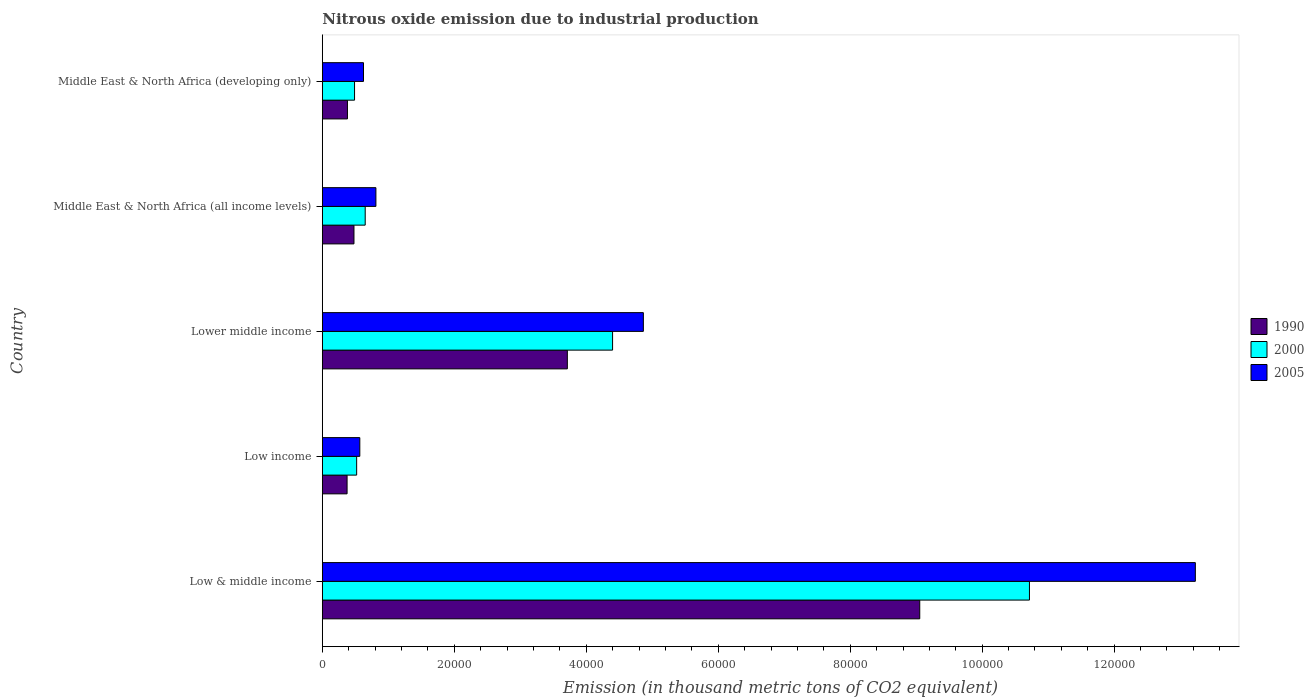How many different coloured bars are there?
Your response must be concise. 3. How many groups of bars are there?
Provide a short and direct response. 5. Are the number of bars per tick equal to the number of legend labels?
Offer a terse response. Yes. How many bars are there on the 5th tick from the top?
Offer a terse response. 3. What is the label of the 1st group of bars from the top?
Your answer should be compact. Middle East & North Africa (developing only). What is the amount of nitrous oxide emitted in 2000 in Low & middle income?
Provide a short and direct response. 1.07e+05. Across all countries, what is the maximum amount of nitrous oxide emitted in 2000?
Your response must be concise. 1.07e+05. Across all countries, what is the minimum amount of nitrous oxide emitted in 2005?
Your response must be concise. 5680.8. In which country was the amount of nitrous oxide emitted in 2005 minimum?
Your answer should be very brief. Low income. What is the total amount of nitrous oxide emitted in 2000 in the graph?
Provide a short and direct response. 1.68e+05. What is the difference between the amount of nitrous oxide emitted in 2005 in Low & middle income and that in Middle East & North Africa (developing only)?
Provide a succinct answer. 1.26e+05. What is the difference between the amount of nitrous oxide emitted in 2000 in Lower middle income and the amount of nitrous oxide emitted in 1990 in Low income?
Keep it short and to the point. 4.02e+04. What is the average amount of nitrous oxide emitted in 2000 per country?
Your answer should be very brief. 3.35e+04. What is the difference between the amount of nitrous oxide emitted in 2005 and amount of nitrous oxide emitted in 2000 in Low income?
Offer a very short reply. 479.3. What is the ratio of the amount of nitrous oxide emitted in 2000 in Low & middle income to that in Middle East & North Africa (developing only)?
Your answer should be compact. 21.95. Is the difference between the amount of nitrous oxide emitted in 2005 in Low income and Middle East & North Africa (developing only) greater than the difference between the amount of nitrous oxide emitted in 2000 in Low income and Middle East & North Africa (developing only)?
Offer a terse response. No. What is the difference between the highest and the second highest amount of nitrous oxide emitted in 2005?
Your response must be concise. 8.37e+04. What is the difference between the highest and the lowest amount of nitrous oxide emitted in 2005?
Give a very brief answer. 1.27e+05. In how many countries, is the amount of nitrous oxide emitted in 1990 greater than the average amount of nitrous oxide emitted in 1990 taken over all countries?
Offer a terse response. 2. Is the sum of the amount of nitrous oxide emitted in 1990 in Low & middle income and Low income greater than the maximum amount of nitrous oxide emitted in 2000 across all countries?
Offer a terse response. No. How many bars are there?
Give a very brief answer. 15. What is the difference between two consecutive major ticks on the X-axis?
Provide a succinct answer. 2.00e+04. Does the graph contain grids?
Provide a short and direct response. No. Where does the legend appear in the graph?
Offer a very short reply. Center right. How many legend labels are there?
Make the answer very short. 3. What is the title of the graph?
Ensure brevity in your answer.  Nitrous oxide emission due to industrial production. Does "2001" appear as one of the legend labels in the graph?
Your answer should be compact. No. What is the label or title of the X-axis?
Provide a short and direct response. Emission (in thousand metric tons of CO2 equivalent). What is the Emission (in thousand metric tons of CO2 equivalent) in 1990 in Low & middle income?
Keep it short and to the point. 9.05e+04. What is the Emission (in thousand metric tons of CO2 equivalent) of 2000 in Low & middle income?
Ensure brevity in your answer.  1.07e+05. What is the Emission (in thousand metric tons of CO2 equivalent) in 2005 in Low & middle income?
Give a very brief answer. 1.32e+05. What is the Emission (in thousand metric tons of CO2 equivalent) in 1990 in Low income?
Give a very brief answer. 3751.3. What is the Emission (in thousand metric tons of CO2 equivalent) in 2000 in Low income?
Provide a succinct answer. 5201.5. What is the Emission (in thousand metric tons of CO2 equivalent) of 2005 in Low income?
Keep it short and to the point. 5680.8. What is the Emission (in thousand metric tons of CO2 equivalent) of 1990 in Lower middle income?
Your response must be concise. 3.71e+04. What is the Emission (in thousand metric tons of CO2 equivalent) in 2000 in Lower middle income?
Provide a succinct answer. 4.40e+04. What is the Emission (in thousand metric tons of CO2 equivalent) in 2005 in Lower middle income?
Provide a short and direct response. 4.87e+04. What is the Emission (in thousand metric tons of CO2 equivalent) in 1990 in Middle East & North Africa (all income levels)?
Your answer should be very brief. 4795.2. What is the Emission (in thousand metric tons of CO2 equivalent) of 2000 in Middle East & North Africa (all income levels)?
Provide a succinct answer. 6497. What is the Emission (in thousand metric tons of CO2 equivalent) in 2005 in Middle East & North Africa (all income levels)?
Provide a short and direct response. 8118.6. What is the Emission (in thousand metric tons of CO2 equivalent) of 1990 in Middle East & North Africa (developing only)?
Your answer should be very brief. 3806.6. What is the Emission (in thousand metric tons of CO2 equivalent) in 2000 in Middle East & North Africa (developing only)?
Your response must be concise. 4882.9. What is the Emission (in thousand metric tons of CO2 equivalent) of 2005 in Middle East & North Africa (developing only)?
Offer a very short reply. 6239.6. Across all countries, what is the maximum Emission (in thousand metric tons of CO2 equivalent) in 1990?
Your answer should be very brief. 9.05e+04. Across all countries, what is the maximum Emission (in thousand metric tons of CO2 equivalent) of 2000?
Your answer should be compact. 1.07e+05. Across all countries, what is the maximum Emission (in thousand metric tons of CO2 equivalent) of 2005?
Provide a short and direct response. 1.32e+05. Across all countries, what is the minimum Emission (in thousand metric tons of CO2 equivalent) in 1990?
Provide a short and direct response. 3751.3. Across all countries, what is the minimum Emission (in thousand metric tons of CO2 equivalent) in 2000?
Your response must be concise. 4882.9. Across all countries, what is the minimum Emission (in thousand metric tons of CO2 equivalent) in 2005?
Provide a short and direct response. 5680.8. What is the total Emission (in thousand metric tons of CO2 equivalent) of 1990 in the graph?
Offer a very short reply. 1.40e+05. What is the total Emission (in thousand metric tons of CO2 equivalent) of 2000 in the graph?
Provide a short and direct response. 1.68e+05. What is the total Emission (in thousand metric tons of CO2 equivalent) in 2005 in the graph?
Offer a very short reply. 2.01e+05. What is the difference between the Emission (in thousand metric tons of CO2 equivalent) of 1990 in Low & middle income and that in Low income?
Provide a short and direct response. 8.68e+04. What is the difference between the Emission (in thousand metric tons of CO2 equivalent) in 2000 in Low & middle income and that in Low income?
Your answer should be compact. 1.02e+05. What is the difference between the Emission (in thousand metric tons of CO2 equivalent) of 2005 in Low & middle income and that in Low income?
Keep it short and to the point. 1.27e+05. What is the difference between the Emission (in thousand metric tons of CO2 equivalent) in 1990 in Low & middle income and that in Lower middle income?
Your answer should be compact. 5.34e+04. What is the difference between the Emission (in thousand metric tons of CO2 equivalent) in 2000 in Low & middle income and that in Lower middle income?
Your answer should be very brief. 6.32e+04. What is the difference between the Emission (in thousand metric tons of CO2 equivalent) in 2005 in Low & middle income and that in Lower middle income?
Offer a terse response. 8.37e+04. What is the difference between the Emission (in thousand metric tons of CO2 equivalent) in 1990 in Low & middle income and that in Middle East & North Africa (all income levels)?
Your answer should be very brief. 8.57e+04. What is the difference between the Emission (in thousand metric tons of CO2 equivalent) of 2000 in Low & middle income and that in Middle East & North Africa (all income levels)?
Ensure brevity in your answer.  1.01e+05. What is the difference between the Emission (in thousand metric tons of CO2 equivalent) in 2005 in Low & middle income and that in Middle East & North Africa (all income levels)?
Make the answer very short. 1.24e+05. What is the difference between the Emission (in thousand metric tons of CO2 equivalent) in 1990 in Low & middle income and that in Middle East & North Africa (developing only)?
Ensure brevity in your answer.  8.67e+04. What is the difference between the Emission (in thousand metric tons of CO2 equivalent) in 2000 in Low & middle income and that in Middle East & North Africa (developing only)?
Provide a succinct answer. 1.02e+05. What is the difference between the Emission (in thousand metric tons of CO2 equivalent) in 2005 in Low & middle income and that in Middle East & North Africa (developing only)?
Ensure brevity in your answer.  1.26e+05. What is the difference between the Emission (in thousand metric tons of CO2 equivalent) in 1990 in Low income and that in Lower middle income?
Your response must be concise. -3.34e+04. What is the difference between the Emission (in thousand metric tons of CO2 equivalent) of 2000 in Low income and that in Lower middle income?
Provide a short and direct response. -3.88e+04. What is the difference between the Emission (in thousand metric tons of CO2 equivalent) of 2005 in Low income and that in Lower middle income?
Ensure brevity in your answer.  -4.30e+04. What is the difference between the Emission (in thousand metric tons of CO2 equivalent) of 1990 in Low income and that in Middle East & North Africa (all income levels)?
Keep it short and to the point. -1043.9. What is the difference between the Emission (in thousand metric tons of CO2 equivalent) of 2000 in Low income and that in Middle East & North Africa (all income levels)?
Give a very brief answer. -1295.5. What is the difference between the Emission (in thousand metric tons of CO2 equivalent) of 2005 in Low income and that in Middle East & North Africa (all income levels)?
Keep it short and to the point. -2437.8. What is the difference between the Emission (in thousand metric tons of CO2 equivalent) of 1990 in Low income and that in Middle East & North Africa (developing only)?
Your answer should be compact. -55.3. What is the difference between the Emission (in thousand metric tons of CO2 equivalent) in 2000 in Low income and that in Middle East & North Africa (developing only)?
Offer a very short reply. 318.6. What is the difference between the Emission (in thousand metric tons of CO2 equivalent) of 2005 in Low income and that in Middle East & North Africa (developing only)?
Offer a terse response. -558.8. What is the difference between the Emission (in thousand metric tons of CO2 equivalent) of 1990 in Lower middle income and that in Middle East & North Africa (all income levels)?
Your answer should be very brief. 3.23e+04. What is the difference between the Emission (in thousand metric tons of CO2 equivalent) in 2000 in Lower middle income and that in Middle East & North Africa (all income levels)?
Ensure brevity in your answer.  3.75e+04. What is the difference between the Emission (in thousand metric tons of CO2 equivalent) in 2005 in Lower middle income and that in Middle East & North Africa (all income levels)?
Your answer should be very brief. 4.05e+04. What is the difference between the Emission (in thousand metric tons of CO2 equivalent) in 1990 in Lower middle income and that in Middle East & North Africa (developing only)?
Offer a very short reply. 3.33e+04. What is the difference between the Emission (in thousand metric tons of CO2 equivalent) in 2000 in Lower middle income and that in Middle East & North Africa (developing only)?
Offer a very short reply. 3.91e+04. What is the difference between the Emission (in thousand metric tons of CO2 equivalent) in 2005 in Lower middle income and that in Middle East & North Africa (developing only)?
Make the answer very short. 4.24e+04. What is the difference between the Emission (in thousand metric tons of CO2 equivalent) in 1990 in Middle East & North Africa (all income levels) and that in Middle East & North Africa (developing only)?
Your answer should be very brief. 988.6. What is the difference between the Emission (in thousand metric tons of CO2 equivalent) in 2000 in Middle East & North Africa (all income levels) and that in Middle East & North Africa (developing only)?
Ensure brevity in your answer.  1614.1. What is the difference between the Emission (in thousand metric tons of CO2 equivalent) of 2005 in Middle East & North Africa (all income levels) and that in Middle East & North Africa (developing only)?
Ensure brevity in your answer.  1879. What is the difference between the Emission (in thousand metric tons of CO2 equivalent) in 1990 in Low & middle income and the Emission (in thousand metric tons of CO2 equivalent) in 2000 in Low income?
Provide a succinct answer. 8.53e+04. What is the difference between the Emission (in thousand metric tons of CO2 equivalent) of 1990 in Low & middle income and the Emission (in thousand metric tons of CO2 equivalent) of 2005 in Low income?
Make the answer very short. 8.49e+04. What is the difference between the Emission (in thousand metric tons of CO2 equivalent) of 2000 in Low & middle income and the Emission (in thousand metric tons of CO2 equivalent) of 2005 in Low income?
Your response must be concise. 1.01e+05. What is the difference between the Emission (in thousand metric tons of CO2 equivalent) of 1990 in Low & middle income and the Emission (in thousand metric tons of CO2 equivalent) of 2000 in Lower middle income?
Your answer should be compact. 4.66e+04. What is the difference between the Emission (in thousand metric tons of CO2 equivalent) of 1990 in Low & middle income and the Emission (in thousand metric tons of CO2 equivalent) of 2005 in Lower middle income?
Offer a terse response. 4.19e+04. What is the difference between the Emission (in thousand metric tons of CO2 equivalent) of 2000 in Low & middle income and the Emission (in thousand metric tons of CO2 equivalent) of 2005 in Lower middle income?
Offer a terse response. 5.85e+04. What is the difference between the Emission (in thousand metric tons of CO2 equivalent) in 1990 in Low & middle income and the Emission (in thousand metric tons of CO2 equivalent) in 2000 in Middle East & North Africa (all income levels)?
Offer a terse response. 8.40e+04. What is the difference between the Emission (in thousand metric tons of CO2 equivalent) in 1990 in Low & middle income and the Emission (in thousand metric tons of CO2 equivalent) in 2005 in Middle East & North Africa (all income levels)?
Your answer should be very brief. 8.24e+04. What is the difference between the Emission (in thousand metric tons of CO2 equivalent) in 2000 in Low & middle income and the Emission (in thousand metric tons of CO2 equivalent) in 2005 in Middle East & North Africa (all income levels)?
Your answer should be very brief. 9.90e+04. What is the difference between the Emission (in thousand metric tons of CO2 equivalent) of 1990 in Low & middle income and the Emission (in thousand metric tons of CO2 equivalent) of 2000 in Middle East & North Africa (developing only)?
Make the answer very short. 8.57e+04. What is the difference between the Emission (in thousand metric tons of CO2 equivalent) in 1990 in Low & middle income and the Emission (in thousand metric tons of CO2 equivalent) in 2005 in Middle East & North Africa (developing only)?
Provide a succinct answer. 8.43e+04. What is the difference between the Emission (in thousand metric tons of CO2 equivalent) in 2000 in Low & middle income and the Emission (in thousand metric tons of CO2 equivalent) in 2005 in Middle East & North Africa (developing only)?
Provide a succinct answer. 1.01e+05. What is the difference between the Emission (in thousand metric tons of CO2 equivalent) of 1990 in Low income and the Emission (in thousand metric tons of CO2 equivalent) of 2000 in Lower middle income?
Your answer should be very brief. -4.02e+04. What is the difference between the Emission (in thousand metric tons of CO2 equivalent) of 1990 in Low income and the Emission (in thousand metric tons of CO2 equivalent) of 2005 in Lower middle income?
Ensure brevity in your answer.  -4.49e+04. What is the difference between the Emission (in thousand metric tons of CO2 equivalent) in 2000 in Low income and the Emission (in thousand metric tons of CO2 equivalent) in 2005 in Lower middle income?
Your answer should be very brief. -4.35e+04. What is the difference between the Emission (in thousand metric tons of CO2 equivalent) of 1990 in Low income and the Emission (in thousand metric tons of CO2 equivalent) of 2000 in Middle East & North Africa (all income levels)?
Give a very brief answer. -2745.7. What is the difference between the Emission (in thousand metric tons of CO2 equivalent) in 1990 in Low income and the Emission (in thousand metric tons of CO2 equivalent) in 2005 in Middle East & North Africa (all income levels)?
Provide a short and direct response. -4367.3. What is the difference between the Emission (in thousand metric tons of CO2 equivalent) in 2000 in Low income and the Emission (in thousand metric tons of CO2 equivalent) in 2005 in Middle East & North Africa (all income levels)?
Offer a very short reply. -2917.1. What is the difference between the Emission (in thousand metric tons of CO2 equivalent) of 1990 in Low income and the Emission (in thousand metric tons of CO2 equivalent) of 2000 in Middle East & North Africa (developing only)?
Keep it short and to the point. -1131.6. What is the difference between the Emission (in thousand metric tons of CO2 equivalent) of 1990 in Low income and the Emission (in thousand metric tons of CO2 equivalent) of 2005 in Middle East & North Africa (developing only)?
Offer a very short reply. -2488.3. What is the difference between the Emission (in thousand metric tons of CO2 equivalent) in 2000 in Low income and the Emission (in thousand metric tons of CO2 equivalent) in 2005 in Middle East & North Africa (developing only)?
Offer a very short reply. -1038.1. What is the difference between the Emission (in thousand metric tons of CO2 equivalent) of 1990 in Lower middle income and the Emission (in thousand metric tons of CO2 equivalent) of 2000 in Middle East & North Africa (all income levels)?
Your response must be concise. 3.06e+04. What is the difference between the Emission (in thousand metric tons of CO2 equivalent) of 1990 in Lower middle income and the Emission (in thousand metric tons of CO2 equivalent) of 2005 in Middle East & North Africa (all income levels)?
Provide a succinct answer. 2.90e+04. What is the difference between the Emission (in thousand metric tons of CO2 equivalent) of 2000 in Lower middle income and the Emission (in thousand metric tons of CO2 equivalent) of 2005 in Middle East & North Africa (all income levels)?
Your response must be concise. 3.59e+04. What is the difference between the Emission (in thousand metric tons of CO2 equivalent) of 1990 in Lower middle income and the Emission (in thousand metric tons of CO2 equivalent) of 2000 in Middle East & North Africa (developing only)?
Your response must be concise. 3.22e+04. What is the difference between the Emission (in thousand metric tons of CO2 equivalent) in 1990 in Lower middle income and the Emission (in thousand metric tons of CO2 equivalent) in 2005 in Middle East & North Africa (developing only)?
Your response must be concise. 3.09e+04. What is the difference between the Emission (in thousand metric tons of CO2 equivalent) of 2000 in Lower middle income and the Emission (in thousand metric tons of CO2 equivalent) of 2005 in Middle East & North Africa (developing only)?
Your response must be concise. 3.77e+04. What is the difference between the Emission (in thousand metric tons of CO2 equivalent) of 1990 in Middle East & North Africa (all income levels) and the Emission (in thousand metric tons of CO2 equivalent) of 2000 in Middle East & North Africa (developing only)?
Your answer should be compact. -87.7. What is the difference between the Emission (in thousand metric tons of CO2 equivalent) in 1990 in Middle East & North Africa (all income levels) and the Emission (in thousand metric tons of CO2 equivalent) in 2005 in Middle East & North Africa (developing only)?
Your response must be concise. -1444.4. What is the difference between the Emission (in thousand metric tons of CO2 equivalent) in 2000 in Middle East & North Africa (all income levels) and the Emission (in thousand metric tons of CO2 equivalent) in 2005 in Middle East & North Africa (developing only)?
Ensure brevity in your answer.  257.4. What is the average Emission (in thousand metric tons of CO2 equivalent) of 1990 per country?
Offer a very short reply. 2.80e+04. What is the average Emission (in thousand metric tons of CO2 equivalent) of 2000 per country?
Give a very brief answer. 3.35e+04. What is the average Emission (in thousand metric tons of CO2 equivalent) of 2005 per country?
Make the answer very short. 4.02e+04. What is the difference between the Emission (in thousand metric tons of CO2 equivalent) in 1990 and Emission (in thousand metric tons of CO2 equivalent) in 2000 in Low & middle income?
Make the answer very short. -1.66e+04. What is the difference between the Emission (in thousand metric tons of CO2 equivalent) of 1990 and Emission (in thousand metric tons of CO2 equivalent) of 2005 in Low & middle income?
Your answer should be compact. -4.18e+04. What is the difference between the Emission (in thousand metric tons of CO2 equivalent) of 2000 and Emission (in thousand metric tons of CO2 equivalent) of 2005 in Low & middle income?
Your response must be concise. -2.51e+04. What is the difference between the Emission (in thousand metric tons of CO2 equivalent) in 1990 and Emission (in thousand metric tons of CO2 equivalent) in 2000 in Low income?
Keep it short and to the point. -1450.2. What is the difference between the Emission (in thousand metric tons of CO2 equivalent) in 1990 and Emission (in thousand metric tons of CO2 equivalent) in 2005 in Low income?
Offer a terse response. -1929.5. What is the difference between the Emission (in thousand metric tons of CO2 equivalent) in 2000 and Emission (in thousand metric tons of CO2 equivalent) in 2005 in Low income?
Provide a succinct answer. -479.3. What is the difference between the Emission (in thousand metric tons of CO2 equivalent) in 1990 and Emission (in thousand metric tons of CO2 equivalent) in 2000 in Lower middle income?
Keep it short and to the point. -6854.5. What is the difference between the Emission (in thousand metric tons of CO2 equivalent) in 1990 and Emission (in thousand metric tons of CO2 equivalent) in 2005 in Lower middle income?
Offer a very short reply. -1.15e+04. What is the difference between the Emission (in thousand metric tons of CO2 equivalent) in 2000 and Emission (in thousand metric tons of CO2 equivalent) in 2005 in Lower middle income?
Ensure brevity in your answer.  -4665.5. What is the difference between the Emission (in thousand metric tons of CO2 equivalent) in 1990 and Emission (in thousand metric tons of CO2 equivalent) in 2000 in Middle East & North Africa (all income levels)?
Ensure brevity in your answer.  -1701.8. What is the difference between the Emission (in thousand metric tons of CO2 equivalent) of 1990 and Emission (in thousand metric tons of CO2 equivalent) of 2005 in Middle East & North Africa (all income levels)?
Provide a short and direct response. -3323.4. What is the difference between the Emission (in thousand metric tons of CO2 equivalent) of 2000 and Emission (in thousand metric tons of CO2 equivalent) of 2005 in Middle East & North Africa (all income levels)?
Your answer should be compact. -1621.6. What is the difference between the Emission (in thousand metric tons of CO2 equivalent) of 1990 and Emission (in thousand metric tons of CO2 equivalent) of 2000 in Middle East & North Africa (developing only)?
Offer a very short reply. -1076.3. What is the difference between the Emission (in thousand metric tons of CO2 equivalent) in 1990 and Emission (in thousand metric tons of CO2 equivalent) in 2005 in Middle East & North Africa (developing only)?
Your answer should be compact. -2433. What is the difference between the Emission (in thousand metric tons of CO2 equivalent) of 2000 and Emission (in thousand metric tons of CO2 equivalent) of 2005 in Middle East & North Africa (developing only)?
Your answer should be very brief. -1356.7. What is the ratio of the Emission (in thousand metric tons of CO2 equivalent) of 1990 in Low & middle income to that in Low income?
Offer a very short reply. 24.14. What is the ratio of the Emission (in thousand metric tons of CO2 equivalent) of 2000 in Low & middle income to that in Low income?
Offer a terse response. 20.6. What is the ratio of the Emission (in thousand metric tons of CO2 equivalent) of 2005 in Low & middle income to that in Low income?
Your answer should be compact. 23.29. What is the ratio of the Emission (in thousand metric tons of CO2 equivalent) of 1990 in Low & middle income to that in Lower middle income?
Your answer should be compact. 2.44. What is the ratio of the Emission (in thousand metric tons of CO2 equivalent) of 2000 in Low & middle income to that in Lower middle income?
Ensure brevity in your answer.  2.44. What is the ratio of the Emission (in thousand metric tons of CO2 equivalent) of 2005 in Low & middle income to that in Lower middle income?
Your answer should be compact. 2.72. What is the ratio of the Emission (in thousand metric tons of CO2 equivalent) in 1990 in Low & middle income to that in Middle East & North Africa (all income levels)?
Give a very brief answer. 18.88. What is the ratio of the Emission (in thousand metric tons of CO2 equivalent) of 2000 in Low & middle income to that in Middle East & North Africa (all income levels)?
Ensure brevity in your answer.  16.49. What is the ratio of the Emission (in thousand metric tons of CO2 equivalent) of 2005 in Low & middle income to that in Middle East & North Africa (all income levels)?
Your answer should be compact. 16.3. What is the ratio of the Emission (in thousand metric tons of CO2 equivalent) of 1990 in Low & middle income to that in Middle East & North Africa (developing only)?
Offer a terse response. 23.78. What is the ratio of the Emission (in thousand metric tons of CO2 equivalent) of 2000 in Low & middle income to that in Middle East & North Africa (developing only)?
Offer a terse response. 21.95. What is the ratio of the Emission (in thousand metric tons of CO2 equivalent) in 2005 in Low & middle income to that in Middle East & North Africa (developing only)?
Provide a succinct answer. 21.2. What is the ratio of the Emission (in thousand metric tons of CO2 equivalent) of 1990 in Low income to that in Lower middle income?
Give a very brief answer. 0.1. What is the ratio of the Emission (in thousand metric tons of CO2 equivalent) of 2000 in Low income to that in Lower middle income?
Provide a short and direct response. 0.12. What is the ratio of the Emission (in thousand metric tons of CO2 equivalent) of 2005 in Low income to that in Lower middle income?
Your response must be concise. 0.12. What is the ratio of the Emission (in thousand metric tons of CO2 equivalent) of 1990 in Low income to that in Middle East & North Africa (all income levels)?
Ensure brevity in your answer.  0.78. What is the ratio of the Emission (in thousand metric tons of CO2 equivalent) in 2000 in Low income to that in Middle East & North Africa (all income levels)?
Provide a succinct answer. 0.8. What is the ratio of the Emission (in thousand metric tons of CO2 equivalent) in 2005 in Low income to that in Middle East & North Africa (all income levels)?
Provide a succinct answer. 0.7. What is the ratio of the Emission (in thousand metric tons of CO2 equivalent) of 1990 in Low income to that in Middle East & North Africa (developing only)?
Make the answer very short. 0.99. What is the ratio of the Emission (in thousand metric tons of CO2 equivalent) in 2000 in Low income to that in Middle East & North Africa (developing only)?
Your response must be concise. 1.07. What is the ratio of the Emission (in thousand metric tons of CO2 equivalent) of 2005 in Low income to that in Middle East & North Africa (developing only)?
Make the answer very short. 0.91. What is the ratio of the Emission (in thousand metric tons of CO2 equivalent) in 1990 in Lower middle income to that in Middle East & North Africa (all income levels)?
Provide a short and direct response. 7.74. What is the ratio of the Emission (in thousand metric tons of CO2 equivalent) in 2000 in Lower middle income to that in Middle East & North Africa (all income levels)?
Provide a succinct answer. 6.77. What is the ratio of the Emission (in thousand metric tons of CO2 equivalent) of 2005 in Lower middle income to that in Middle East & North Africa (all income levels)?
Your response must be concise. 5.99. What is the ratio of the Emission (in thousand metric tons of CO2 equivalent) of 1990 in Lower middle income to that in Middle East & North Africa (developing only)?
Your response must be concise. 9.75. What is the ratio of the Emission (in thousand metric tons of CO2 equivalent) of 2000 in Lower middle income to that in Middle East & North Africa (developing only)?
Ensure brevity in your answer.  9.01. What is the ratio of the Emission (in thousand metric tons of CO2 equivalent) of 2005 in Lower middle income to that in Middle East & North Africa (developing only)?
Offer a terse response. 7.8. What is the ratio of the Emission (in thousand metric tons of CO2 equivalent) of 1990 in Middle East & North Africa (all income levels) to that in Middle East & North Africa (developing only)?
Give a very brief answer. 1.26. What is the ratio of the Emission (in thousand metric tons of CO2 equivalent) of 2000 in Middle East & North Africa (all income levels) to that in Middle East & North Africa (developing only)?
Offer a terse response. 1.33. What is the ratio of the Emission (in thousand metric tons of CO2 equivalent) in 2005 in Middle East & North Africa (all income levels) to that in Middle East & North Africa (developing only)?
Your answer should be compact. 1.3. What is the difference between the highest and the second highest Emission (in thousand metric tons of CO2 equivalent) in 1990?
Make the answer very short. 5.34e+04. What is the difference between the highest and the second highest Emission (in thousand metric tons of CO2 equivalent) of 2000?
Offer a very short reply. 6.32e+04. What is the difference between the highest and the second highest Emission (in thousand metric tons of CO2 equivalent) of 2005?
Keep it short and to the point. 8.37e+04. What is the difference between the highest and the lowest Emission (in thousand metric tons of CO2 equivalent) in 1990?
Keep it short and to the point. 8.68e+04. What is the difference between the highest and the lowest Emission (in thousand metric tons of CO2 equivalent) of 2000?
Your response must be concise. 1.02e+05. What is the difference between the highest and the lowest Emission (in thousand metric tons of CO2 equivalent) of 2005?
Keep it short and to the point. 1.27e+05. 